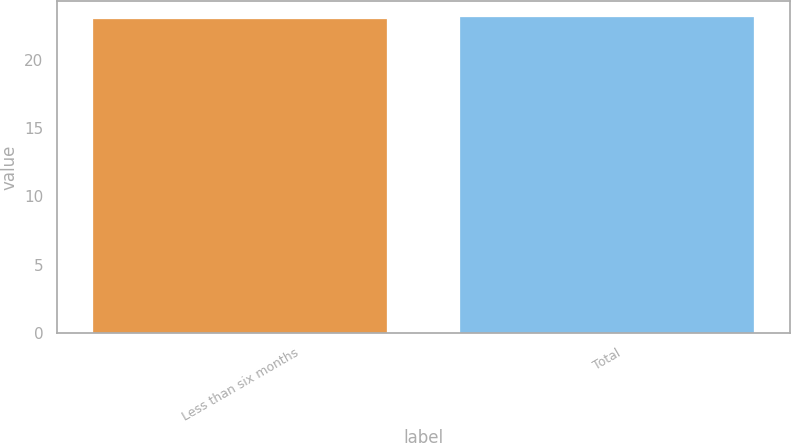<chart> <loc_0><loc_0><loc_500><loc_500><bar_chart><fcel>Less than six months<fcel>Total<nl><fcel>23<fcel>23.1<nl></chart> 